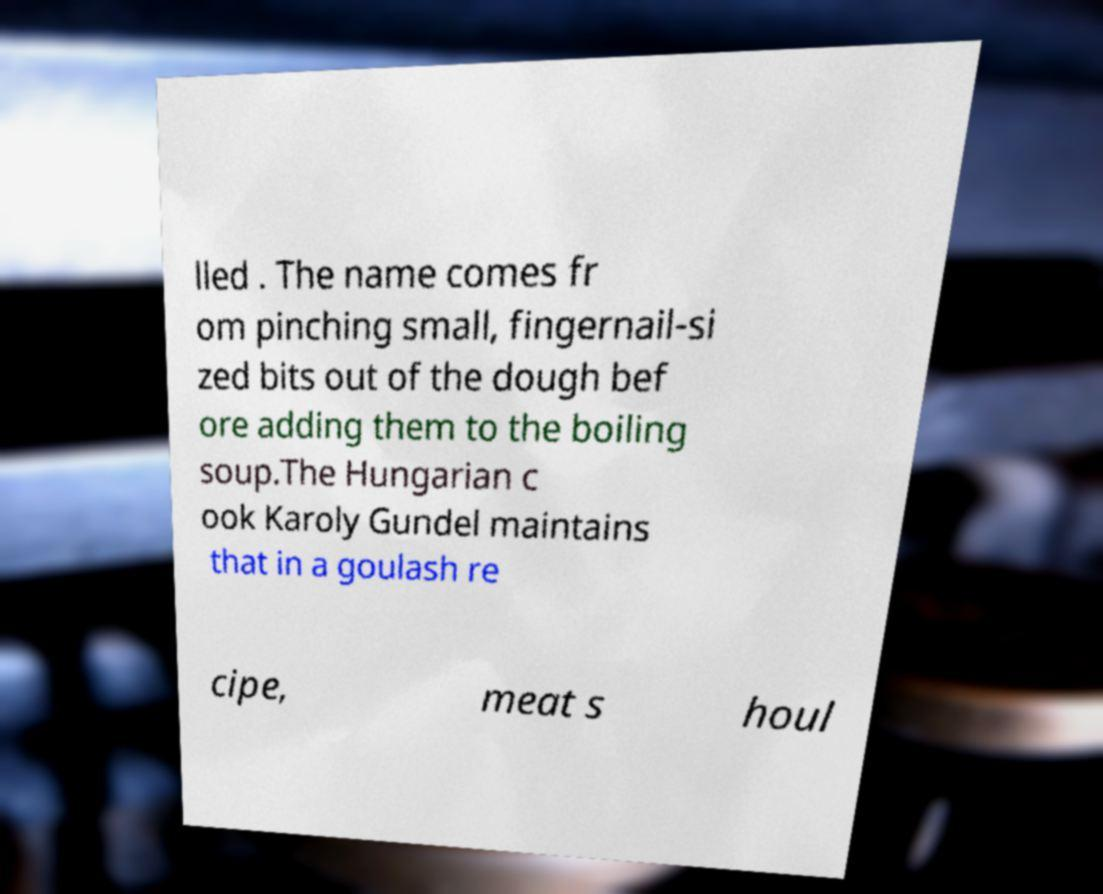I need the written content from this picture converted into text. Can you do that? lled . The name comes fr om pinching small, fingernail-si zed bits out of the dough bef ore adding them to the boiling soup.The Hungarian c ook Karoly Gundel maintains that in a goulash re cipe, meat s houl 